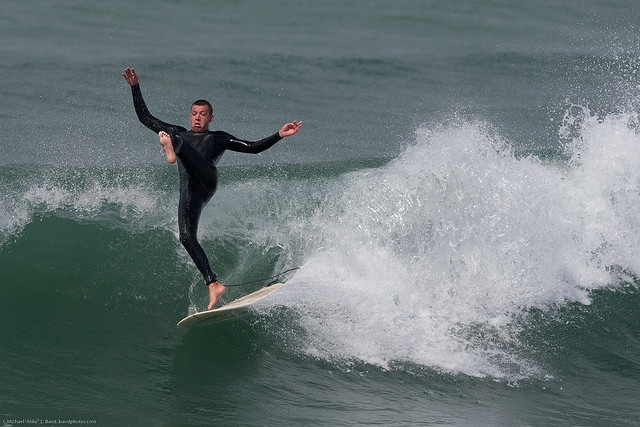Describe the objects in this image and their specific colors. I can see people in gray, black, brown, and maroon tones and surfboard in gray, darkgray, and black tones in this image. 